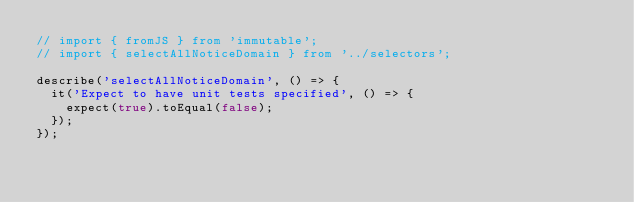Convert code to text. <code><loc_0><loc_0><loc_500><loc_500><_JavaScript_>// import { fromJS } from 'immutable';
// import { selectAllNoticeDomain } from '../selectors';

describe('selectAllNoticeDomain', () => {
  it('Expect to have unit tests specified', () => {
    expect(true).toEqual(false);
  });
});
</code> 